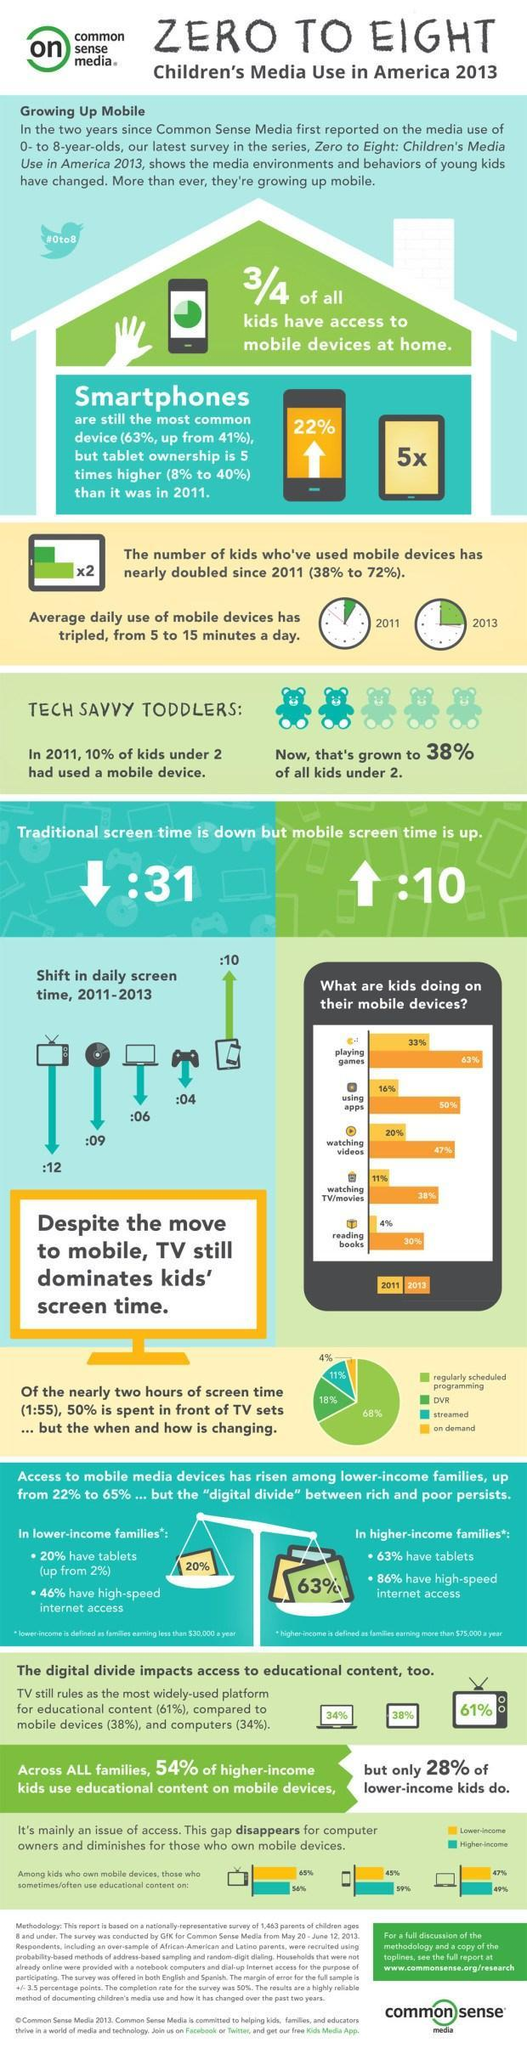What proportion of kids do not have access to mobile devices at home?
Answer the question with a short phrase. 1/4 By what percent has kids who have used mobile devices increased from 2011? 34% What percent of kids watch on demand program? 4% By what percent has tablet ownership grown from 2011? 32% In which year was playing games by kids the highest? 2013 In 2011, what percentage of kids spent their time using apps? 16% By what percent did kids reading books increase from 2011 to 2013? 26% By what percent was kids watching videos lesser in 2011 from 2013? 27% By what percent has kids under 2 using mobile device increased after 2011? 28% Which type of program is watched by 11% of kids as per the pie chart? streamed 